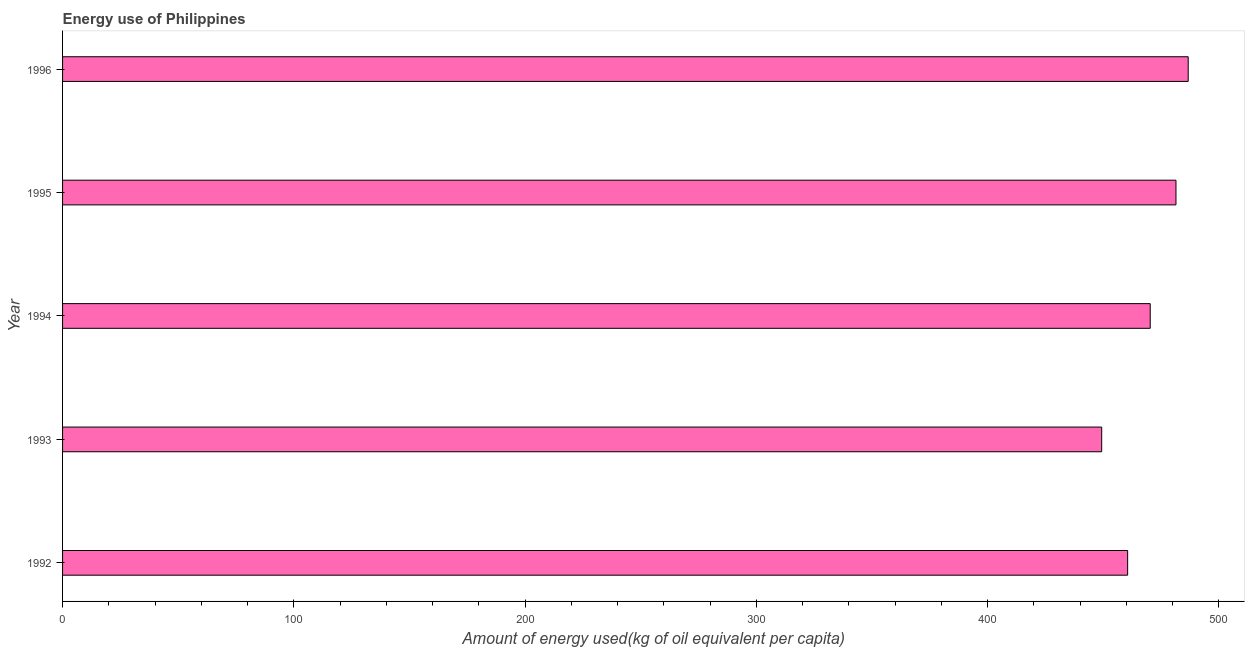Does the graph contain any zero values?
Offer a very short reply. No. Does the graph contain grids?
Offer a very short reply. No. What is the title of the graph?
Offer a terse response. Energy use of Philippines. What is the label or title of the X-axis?
Provide a short and direct response. Amount of energy used(kg of oil equivalent per capita). What is the label or title of the Y-axis?
Make the answer very short. Year. What is the amount of energy used in 1993?
Make the answer very short. 449.32. Across all years, what is the maximum amount of energy used?
Provide a succinct answer. 486.73. Across all years, what is the minimum amount of energy used?
Your response must be concise. 449.32. In which year was the amount of energy used minimum?
Ensure brevity in your answer.  1993. What is the sum of the amount of energy used?
Your answer should be very brief. 2348.35. What is the difference between the amount of energy used in 1992 and 1993?
Give a very brief answer. 11.23. What is the average amount of energy used per year?
Give a very brief answer. 469.67. What is the median amount of energy used?
Offer a terse response. 470.31. In how many years, is the amount of energy used greater than 280 kg?
Keep it short and to the point. 5. Do a majority of the years between 1994 and 1996 (inclusive) have amount of energy used greater than 240 kg?
Keep it short and to the point. Yes. What is the ratio of the amount of energy used in 1993 to that in 1996?
Your answer should be compact. 0.92. Is the amount of energy used in 1994 less than that in 1996?
Your response must be concise. Yes. What is the difference between the highest and the second highest amount of energy used?
Give a very brief answer. 5.29. Is the sum of the amount of energy used in 1992 and 1996 greater than the maximum amount of energy used across all years?
Your answer should be compact. Yes. What is the difference between the highest and the lowest amount of energy used?
Offer a very short reply. 37.41. In how many years, is the amount of energy used greater than the average amount of energy used taken over all years?
Your response must be concise. 3. How many bars are there?
Your response must be concise. 5. Are all the bars in the graph horizontal?
Your response must be concise. Yes. How many years are there in the graph?
Offer a very short reply. 5. What is the Amount of energy used(kg of oil equivalent per capita) of 1992?
Your answer should be very brief. 460.55. What is the Amount of energy used(kg of oil equivalent per capita) in 1993?
Make the answer very short. 449.32. What is the Amount of energy used(kg of oil equivalent per capita) in 1994?
Provide a succinct answer. 470.31. What is the Amount of energy used(kg of oil equivalent per capita) of 1995?
Your answer should be very brief. 481.44. What is the Amount of energy used(kg of oil equivalent per capita) in 1996?
Keep it short and to the point. 486.73. What is the difference between the Amount of energy used(kg of oil equivalent per capita) in 1992 and 1993?
Provide a short and direct response. 11.23. What is the difference between the Amount of energy used(kg of oil equivalent per capita) in 1992 and 1994?
Give a very brief answer. -9.76. What is the difference between the Amount of energy used(kg of oil equivalent per capita) in 1992 and 1995?
Provide a short and direct response. -20.9. What is the difference between the Amount of energy used(kg of oil equivalent per capita) in 1992 and 1996?
Your answer should be very brief. -26.19. What is the difference between the Amount of energy used(kg of oil equivalent per capita) in 1993 and 1994?
Offer a very short reply. -20.99. What is the difference between the Amount of energy used(kg of oil equivalent per capita) in 1993 and 1995?
Ensure brevity in your answer.  -32.12. What is the difference between the Amount of energy used(kg of oil equivalent per capita) in 1993 and 1996?
Offer a terse response. -37.41. What is the difference between the Amount of energy used(kg of oil equivalent per capita) in 1994 and 1995?
Offer a very short reply. -11.13. What is the difference between the Amount of energy used(kg of oil equivalent per capita) in 1994 and 1996?
Offer a terse response. -16.43. What is the difference between the Amount of energy used(kg of oil equivalent per capita) in 1995 and 1996?
Ensure brevity in your answer.  -5.29. What is the ratio of the Amount of energy used(kg of oil equivalent per capita) in 1992 to that in 1994?
Your answer should be compact. 0.98. What is the ratio of the Amount of energy used(kg of oil equivalent per capita) in 1992 to that in 1996?
Your response must be concise. 0.95. What is the ratio of the Amount of energy used(kg of oil equivalent per capita) in 1993 to that in 1994?
Offer a very short reply. 0.95. What is the ratio of the Amount of energy used(kg of oil equivalent per capita) in 1993 to that in 1995?
Provide a short and direct response. 0.93. What is the ratio of the Amount of energy used(kg of oil equivalent per capita) in 1993 to that in 1996?
Your response must be concise. 0.92. What is the ratio of the Amount of energy used(kg of oil equivalent per capita) in 1994 to that in 1995?
Make the answer very short. 0.98. 